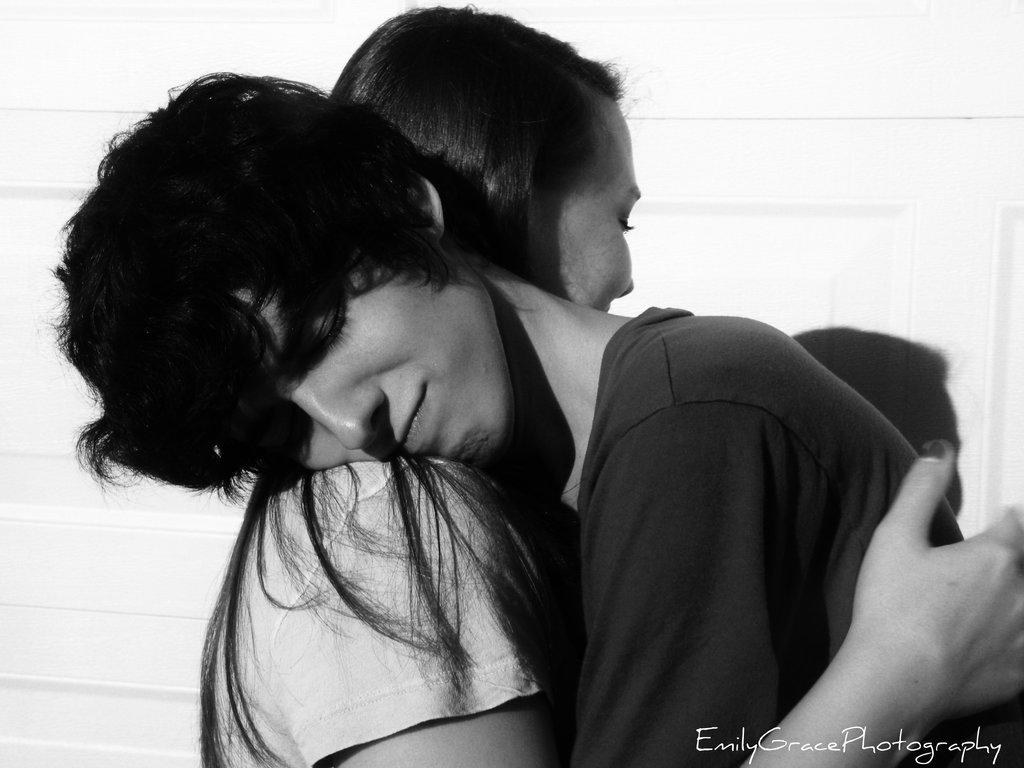What are the genders of the two people in the image? There is a man on the right side of the image and a woman on the left side of the image. Can you describe the positions of the man and woman in the image? The man is on the right side of the image, and the woman is on the left side of the image. Is there any text visible in the image? Yes, there is a watermark text in the bottom right corner of the image. What type of bucket is the man using to polish the floor in the image? There is no bucket or polishing activity present in the image. 